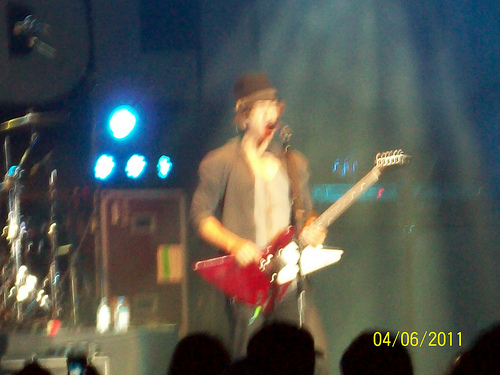<image>
Is there a lights behind the guitar? Yes. From this viewpoint, the lights is positioned behind the guitar, with the guitar partially or fully occluding the lights. Where is the guitar in relation to the man? Is it to the right of the man? No. The guitar is not to the right of the man. The horizontal positioning shows a different relationship. Is the musician in front of the guitar? No. The musician is not in front of the guitar. The spatial positioning shows a different relationship between these objects. 